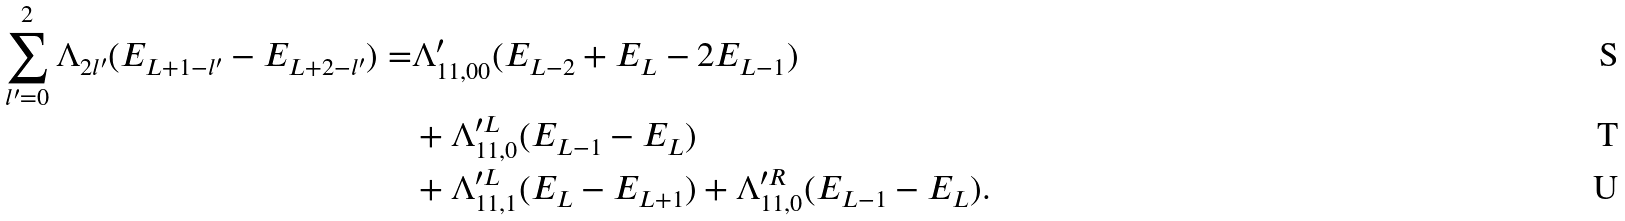<formula> <loc_0><loc_0><loc_500><loc_500>\sum _ { l ^ { \prime } = 0 } ^ { 2 } \Lambda _ { 2 l ^ { \prime } } ( E _ { L + 1 - l ^ { \prime } } - E _ { L + 2 - l ^ { \prime } } ) = & \Lambda ^ { \prime } _ { 1 1 , 0 0 } ( E _ { L - 2 } + E _ { L } - 2 E _ { L - 1 } ) \\ & + \Lambda ^ { \prime L } _ { 1 1 , 0 } ( E _ { L - 1 } - E _ { L } ) \\ & + \Lambda ^ { \prime L } _ { 1 1 , 1 } ( E _ { L } - E _ { L + 1 } ) + \Lambda ^ { \prime R } _ { 1 1 , 0 } ( E _ { L - 1 } - E _ { L } ) .</formula> 